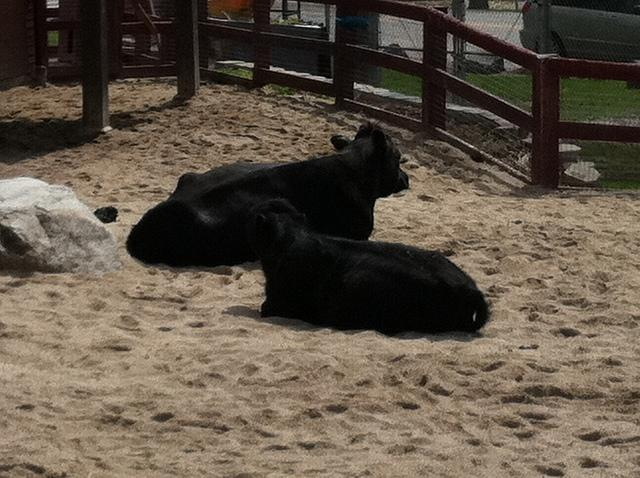What are the cows inside of?

Choices:
A) cardboard boxes
B) fence
C) cages
D) cars fence 